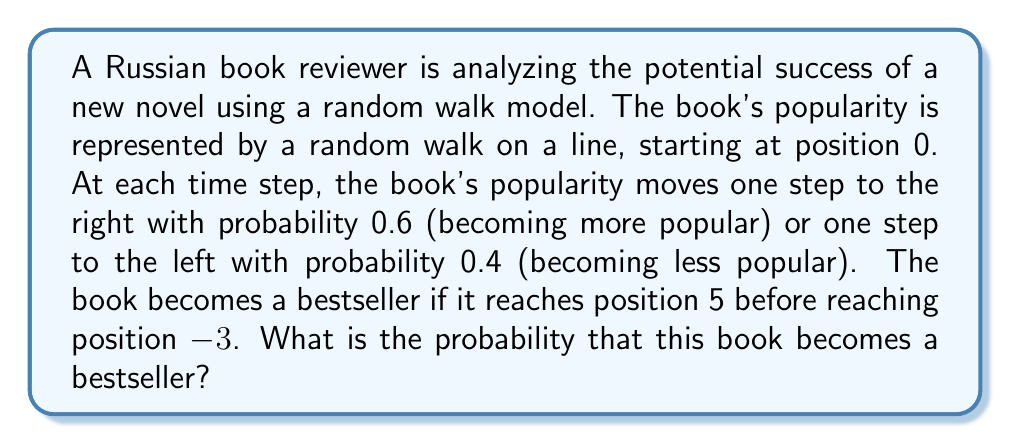Show me your answer to this math problem. Let's approach this step-by-step using the concept of gambler's ruin:

1) Let $p_i$ be the probability of reaching position 5 starting from position $i$ before reaching position -3.

2) We need to find $p_0$.

3) We can set up the following equations:

   $p_{-3} = 0$ (absorbing state)
   $p_5 = 1$ (absorbing state)
   $p_i = 0.6p_{i+1} + 0.4p_{i-1}$ for $-2 \leq i \leq 4$

4) This is a linear difference equation. The general solution has the form:

   $p_i = A + B(\frac{0.4}{0.6})^i = A + B(\frac{2}{3})^i$

5) Using the boundary conditions:

   $p_{-3} = A + B(\frac{2}{3})^{-3} = 0$
   $p_5 = A + B(\frac{2}{3})^5 = 1$

6) Solving these equations:

   $A = \frac{(\frac{2}{3})^5}{(\frac{2}{3})^5 - (\frac{2}{3})^{-3}} \approx 0.8108$
   $B = \frac{-1}{(\frac{2}{3})^5 - (\frac{2}{3})^{-3}} \approx -0.2838$

7) Therefore:

   $p_0 = A + B = \frac{(\frac{2}{3})^5 - 1}{(\frac{2}{3})^5 - (\frac{2}{3})^{-3}} \approx 0.5270$
Answer: $\frac{(\frac{2}{3})^5 - 1}{(\frac{2}{3})^5 - (\frac{2}{3})^{-3}} \approx 0.5270$ 